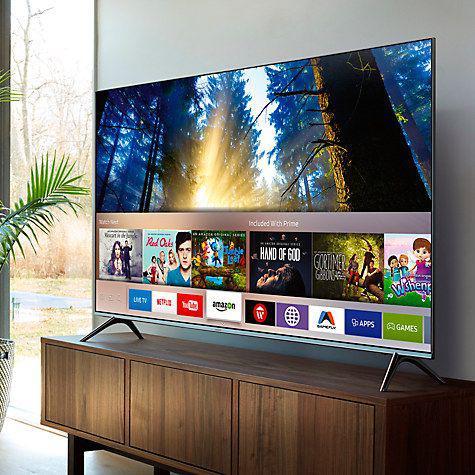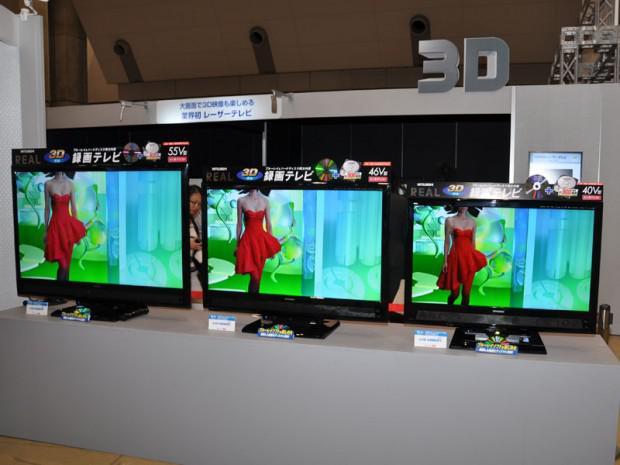The first image is the image on the left, the second image is the image on the right. Analyze the images presented: Is the assertion "The right image contains more operating screens than the left image." valid? Answer yes or no. Yes. The first image is the image on the left, the second image is the image on the right. Examine the images to the left and right. Is the description "There are three monitors increasing in size with identical video being broadcast." accurate? Answer yes or no. Yes. 